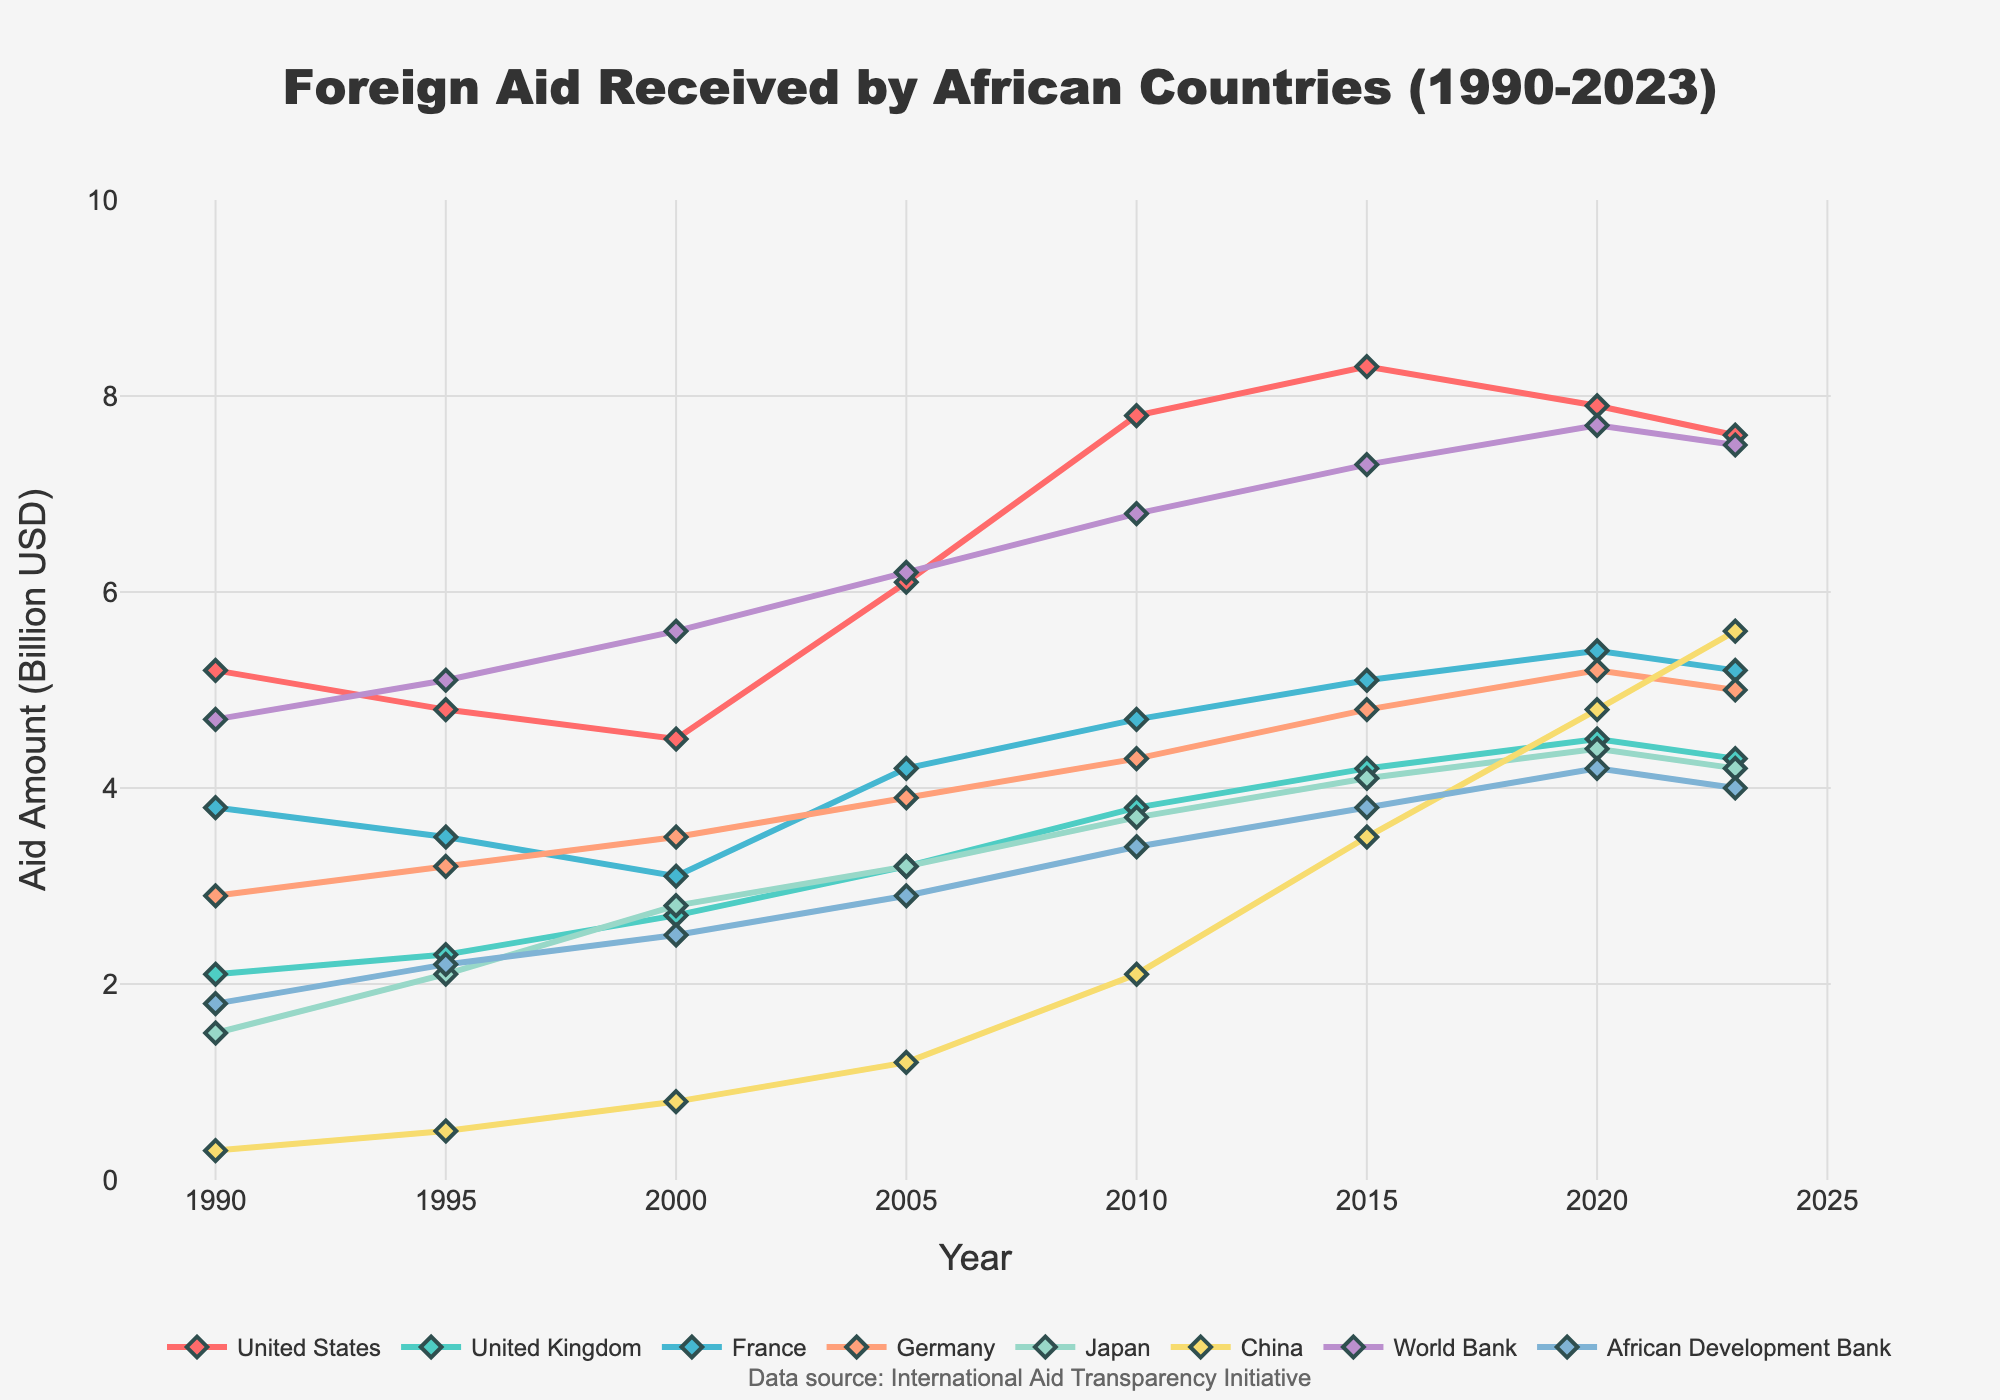What is the overall trend of foreign aid from the United States from 1990 to 2023? From the chart, we can see the line representing the United States' foreign aid. It starts at 5.2 billion USD in 1990, increases to a peak of 8.3 billion USD in 2015, and slightly decreases to 7.6 billion USD in 2023. Thus, the overall trend is an increase, followed by a slight decrease.
Answer: An increase followed by a slight decrease Between China and the World Bank, which donor showed a bigger increase in aid from 1990 to 2023? To find the bigger increase, we need to compare the change for each donor. China's aid increased from 0.3 billion USD in 1990 to 5.6 billion USD in 2023, a change of 5.3 billion USD. The World Bank's aid increased from 4.7 billion USD in 1990 to 7.5 billion USD in 2023, a change of 2.8 billion USD. Thus, China's aid showed a bigger increase.
Answer: China Considering the period from 2000 to 2020, which donor country had the most consistent upward trend in aid? By examining the lines between 2000 and 2020, we can see that Japan, the United Kingdom, and China generally show upward trends. However, China's line appears to be the most consistent, showing a steady increase each year without any decline.
Answer: China Which year did the United Kingdom's aid surpass 4 billion USD for the first time? To determine this, we can trace the United Kingdom's line on the chart and observe the data points. The aid amount for the United Kingdom surpassed 4 billion USD in 2015.
Answer: 2015 How did the aid from France change from 2005 to 2023? The aid from France went from 4.2 billion USD in 2005 to 5.2 billion USD in 2023. The change is calculated as 5.2 - 4.2, which equals an increase of 1.0 billion USD.
Answer: Increased by 1.0 billion USD Which donor had the highest aid amount in 2010? What was that amount? To find this, we look at the data points for the year 2010 for all donors. The United States had the highest aid amount in 2010, which was 7.8 billion USD.
Answer: The United States, 7.8 billion USD What is the period during which Germany's aid grew most rapidly? By analyzing Germany’s line on the chart, it can be observed that the period of most rapid growth is between 1990 and 2020, where the aid increases from 2.9 billion USD to 5.2 billion USD steadily, with the growth accelerating in the last five years of the period.
Answer: 1990-2020, accelerated in last five years Compare the aid from the African Development Bank in 1990 to 2023. What changes do you observe? The African Development Bank's aid was 1.8 billion USD in 1990 and increased to 4.0 billion USD in 2023. The change can be calculated as 4.0 - 1.8, which is an increase of 2.2 billion USD.
Answer: Increased by 2.2 billion USD On average, how much aid did Germany provide annually over the entire period? We need to find the average of Germany's aid from the given years: (2.9 + 3.2 + 3.5 + 3.9 + 4.3 + 4.8 + 5.2 + 5.0) / 8. The sum is 32.8, and the average is 32.8 / 8 = 4.1 billion USD.
Answer: 4.1 billion USD 